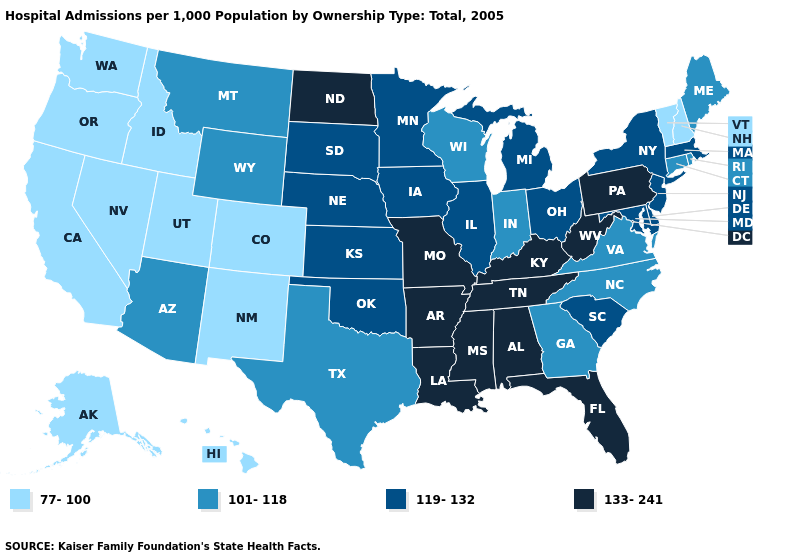Does Minnesota have the highest value in the USA?
Keep it brief. No. Does Vermont have the lowest value in the Northeast?
Keep it brief. Yes. Name the states that have a value in the range 77-100?
Short answer required. Alaska, California, Colorado, Hawaii, Idaho, Nevada, New Hampshire, New Mexico, Oregon, Utah, Vermont, Washington. What is the value of Missouri?
Concise answer only. 133-241. Name the states that have a value in the range 133-241?
Concise answer only. Alabama, Arkansas, Florida, Kentucky, Louisiana, Mississippi, Missouri, North Dakota, Pennsylvania, Tennessee, West Virginia. Among the states that border Rhode Island , does Massachusetts have the lowest value?
Answer briefly. No. Which states have the lowest value in the MidWest?
Give a very brief answer. Indiana, Wisconsin. Does the map have missing data?
Write a very short answer. No. What is the lowest value in the USA?
Write a very short answer. 77-100. What is the highest value in states that border Kansas?
Be succinct. 133-241. Which states have the highest value in the USA?
Keep it brief. Alabama, Arkansas, Florida, Kentucky, Louisiana, Mississippi, Missouri, North Dakota, Pennsylvania, Tennessee, West Virginia. Which states have the lowest value in the West?
Answer briefly. Alaska, California, Colorado, Hawaii, Idaho, Nevada, New Mexico, Oregon, Utah, Washington. Among the states that border Indiana , does Kentucky have the lowest value?
Give a very brief answer. No. Does Arizona have the same value as Alabama?
Be succinct. No. Is the legend a continuous bar?
Short answer required. No. 